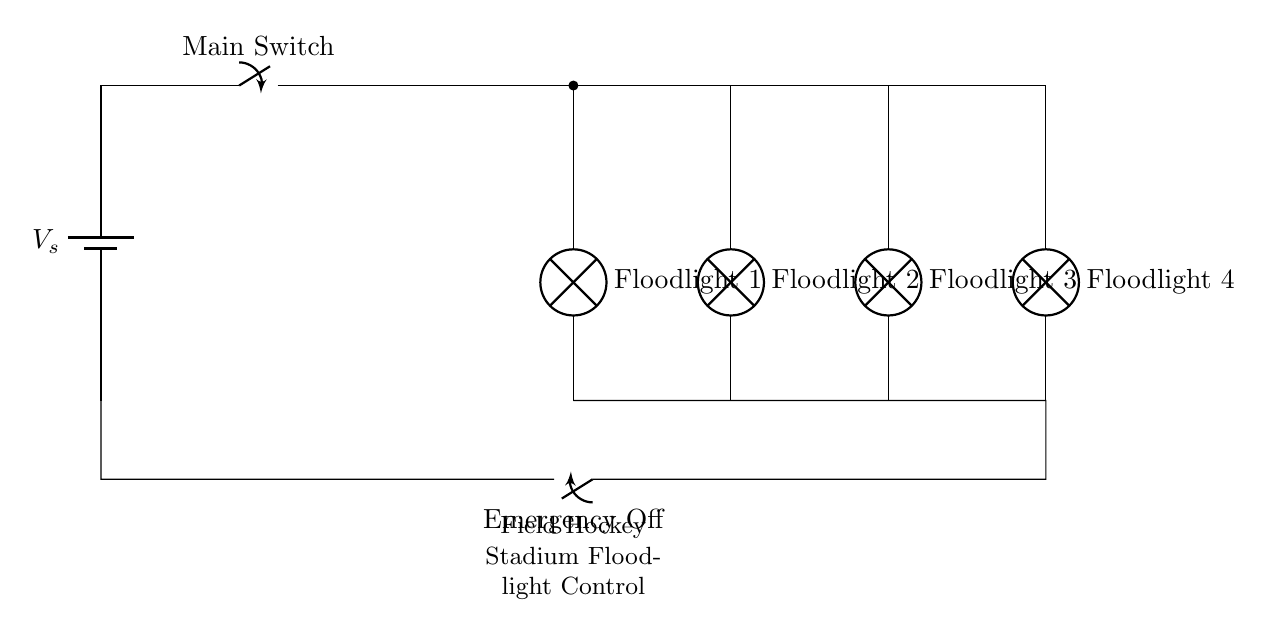What is the power source in this circuit? The power source is represented by the battery symbol labeled as Vs, which provides the necessary voltage for the floodlights.
Answer: Vs How many floodlights are controlled in this circuit? The circuit diagram shows four floodlights connected in parallel, indicated by the four lamp symbols labeled Floodlight 1, Floodlight 2, Floodlight 3, and Floodlight 4.
Answer: Four What type of circuit is this? The circuit is a parallel circuit, as indicated by the arrangement of the floodlights, which allows them to operate independently while sharing the same voltage.
Answer: Parallel What is the purpose of the main switch? The main switch allows for the control of the entire circuit, enabling or disabling power to all floodlights simultaneously.
Answer: Control What happens to the floodlights when the emergency switch is activated? Activating the emergency switch turns off the entire circuit, cutting power to all floodlights for safety purposes.
Answer: All off What is the significance of the arrangement of floodlights? The arrangement in parallel ensures that if one floodlight fails, the others remain operational, improving reliability for the stadium lighting.
Answer: Reliability How is the ground connection represented in this circuit? The ground connection is typically provided at the bottom of each component and in the circuit it connects all the floodlights back to a common path at the same electrical potential.
Answer: Common path 